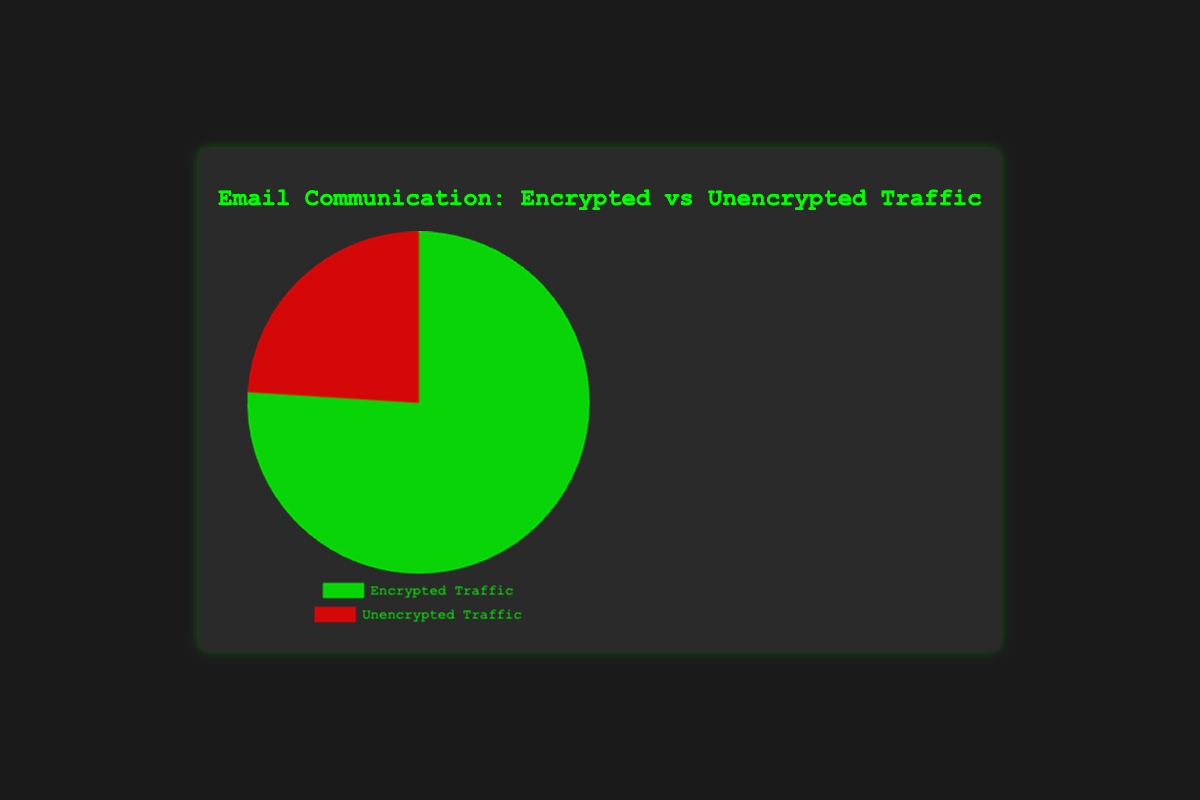What percentage of email communication is encrypted? The figure shows that 76% of email communication is encrypted.
Answer: 76% What percentage of email communication is unencrypted? The figure shows that 24% of email communication is unencrypted.
Answer: 24% What is the combined percentage of encrypted and unencrypted email communication? Adding the percentages of encrypted and unencrypted email communications: 76% + 24% = 100%
Answer: 100% Which type of email communication traffic is greater, encrypted or unencrypted? The encrypted traffic is 76%, which is greater than the unencrypted traffic at 24%.
Answer: Encrypted Traffic By how much is the percentage of encrypted email traffic greater than the unencrypted email traffic? Subtracting the unencrypted traffic percentage from the encrypted traffic percentage: 76% - 24% = 52%
Answer: 52% Which color represents encrypted email traffic in the pie chart? The color used for encrypted traffic in the chart is green.
Answer: Green Which color represents unencrypted email traffic in the pie chart? The color used for unencrypted traffic in the chart is red.
Answer: Red What is the ratio of encrypted to unencrypted email communication? The ratio of encrypted to unencrypted email traffic is 76:24, which simplifies to 19:6.
Answer: 19:6 